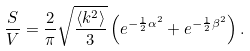<formula> <loc_0><loc_0><loc_500><loc_500>\frac { S } { V } = \frac { 2 } { \pi } \sqrt { \frac { \langle k ^ { 2 } \rangle } { 3 } } \left ( { e ^ { - \frac { 1 } { 2 } { \alpha ^ { 2 } } } + e ^ { - \frac { 1 } { 2 } { \beta ^ { 2 } } } } \right ) .</formula> 